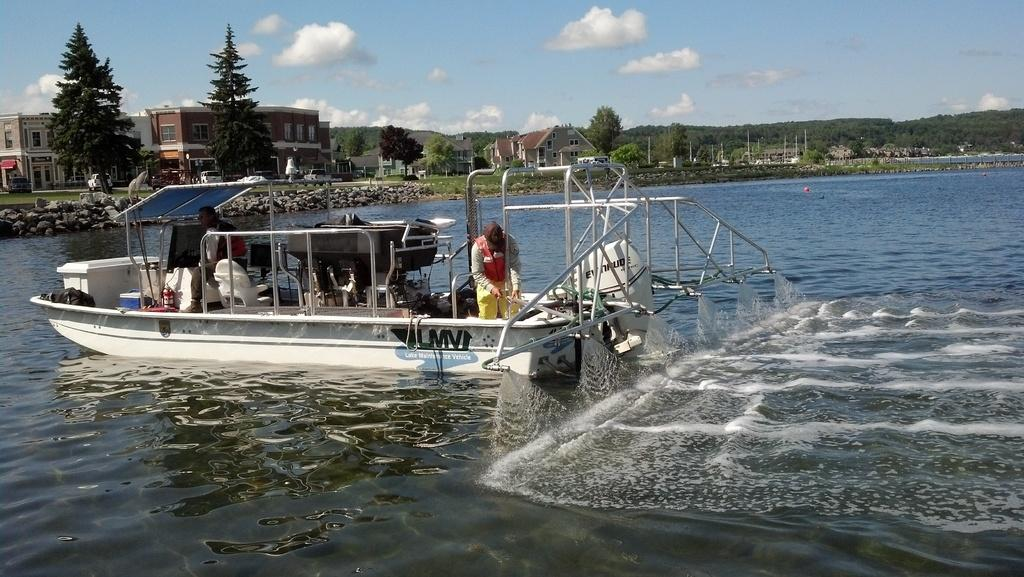What is the main subject of the image? The main subject of the image is a boat. How many people are in the boat? There are two people in the boat. Where is the boat located? The boat is in a river. What type of vegetation can be seen in the image? There are trees and plants visible in the image. What type of structures can be seen in the image? There are houses, buildings, and mountains visible in the image. What type of lift can be seen in the image? There is no lift present in the image. What color is the grass in the image? There is no grass visible in the image. 